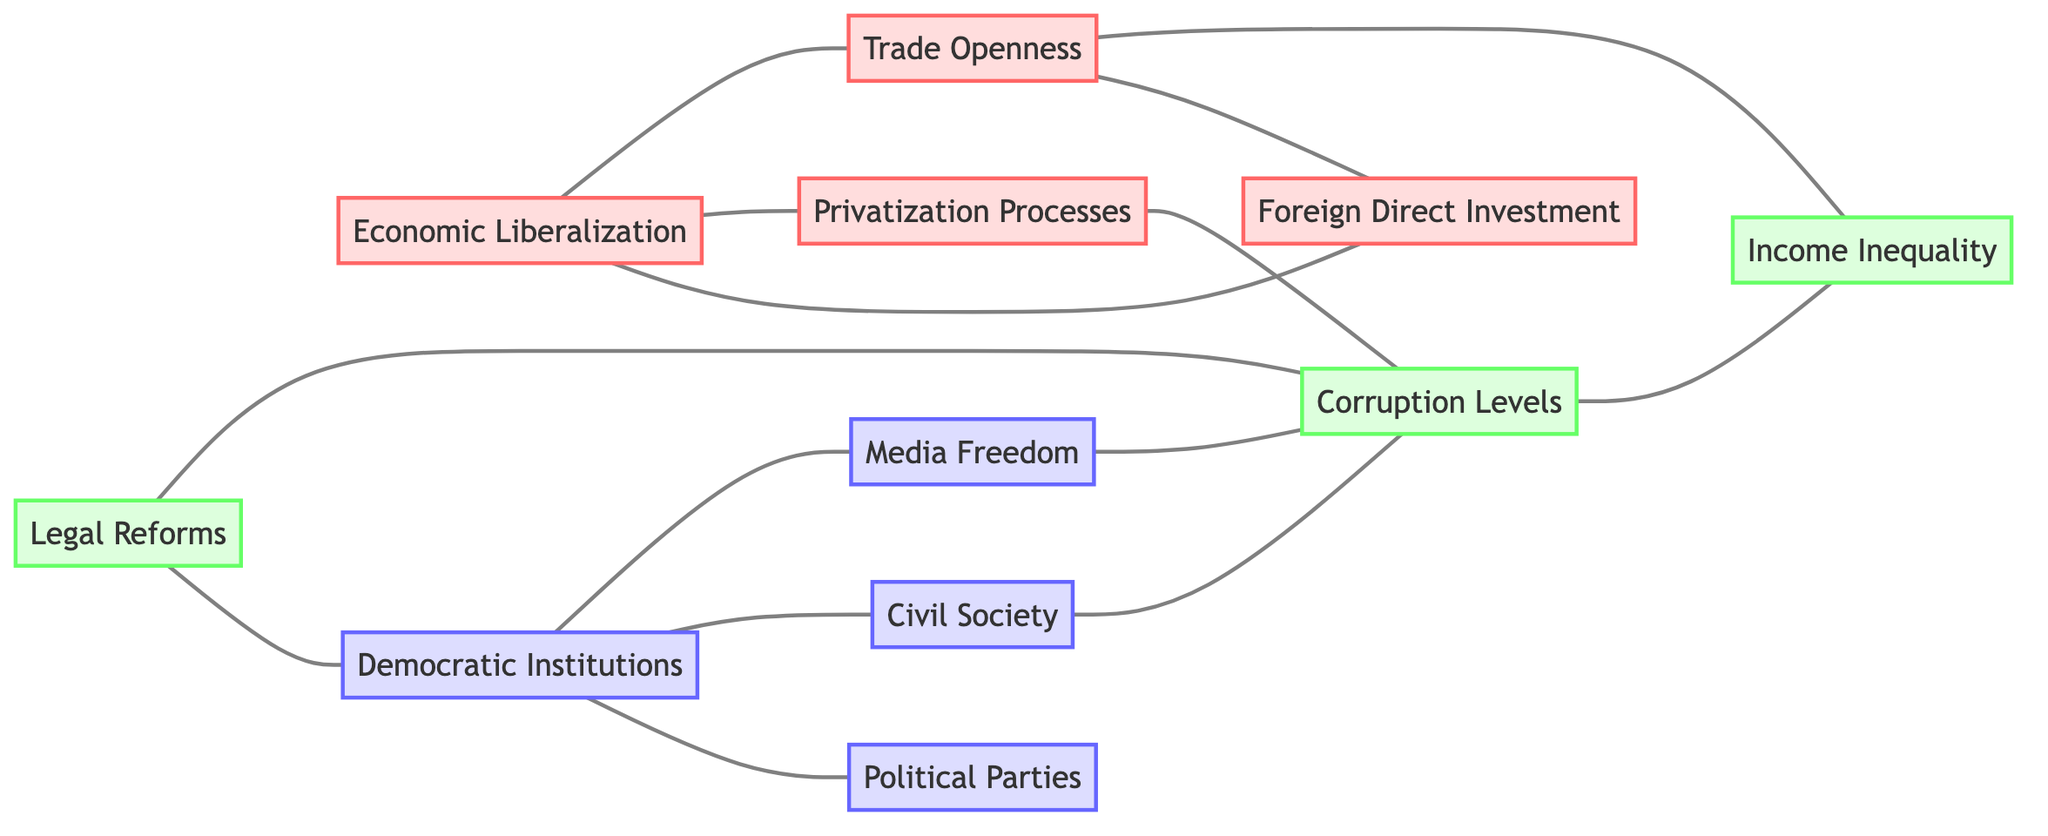What is the total number of nodes in the diagram? To find the total number of nodes, count each unique node listed in the data: Economic Liberalization, Democratic Institutions, Foreign Direct Investment, Political Parties, Civil Society, Legal Reforms, Corruption Levels, Privatization Processes, Media Freedom, Income Inequality, Trade Openness. There are a total of 11 nodes.
Answer: 11 Which two nodes are directly connected to Economic Liberalization? Examine the edges connected to the Economic Liberalization node: it is connected to Foreign Direct Investment, Privatization Processes, and Trade Openness. The question asks for two, so any two of these is acceptable. Here, Foreign Direct Investment and Privatization Processes will be selected.
Answer: Foreign Direct Investment, Privatization Processes Do Economic Liberalization and Democratic Institutions share a direct connection? Determine if there is an edge directly connecting Economic Liberalization and Democratic Institutions in the diagram. There is no edge between these two nodes, meaning they do not share a direct connection.
Answer: No How many edges are there in the diagram? Count the edges listed in the data section. There are a total of 13 edges connecting the nodes.
Answer: 13 Which node is connected to both Legal Reforms and Corruption Levels? Analyze which nodes connect to Legal Reforms and whether they have a direct connection to Corruption Levels. From the edges, Legal Reforms connects to Democratic Institutions and Corruption Levels, making Corruption Levels the common connection between them.
Answer: Corruption Levels How many nodes are connected to Democratic Institutions? Look at the edges connected to Democratic Institutions: Political Parties, Civil Society, Media Freedom, and Legal Reforms. Count them, resulting in four connections.
Answer: 4 What are the two edges that connect to Trade Openness? Identify the edges leading from Trade Openness: it is connected to Foreign Direct Investment and Income Inequality. These are two valid edges that connect to Trade Openness.
Answer: Foreign Direct Investment, Income Inequality Is there a connection between Media Freedom and Income Inequality? Check if there is a direct edge between Media Freedom and Income Inequality in the diagram. According to the edges, there is no direct connection between these two nodes.
Answer: No Which node has the most connections in the diagram? Analyze the degree of each node based on the edges connected. Economic Liberalization, Democratic Institutions, and Corruption Levels all appear connected to multiple other nodes. Counting the connections reveals that Corruption Levels is connected to four nodes, making it the most connected node.
Answer: Corruption Levels 